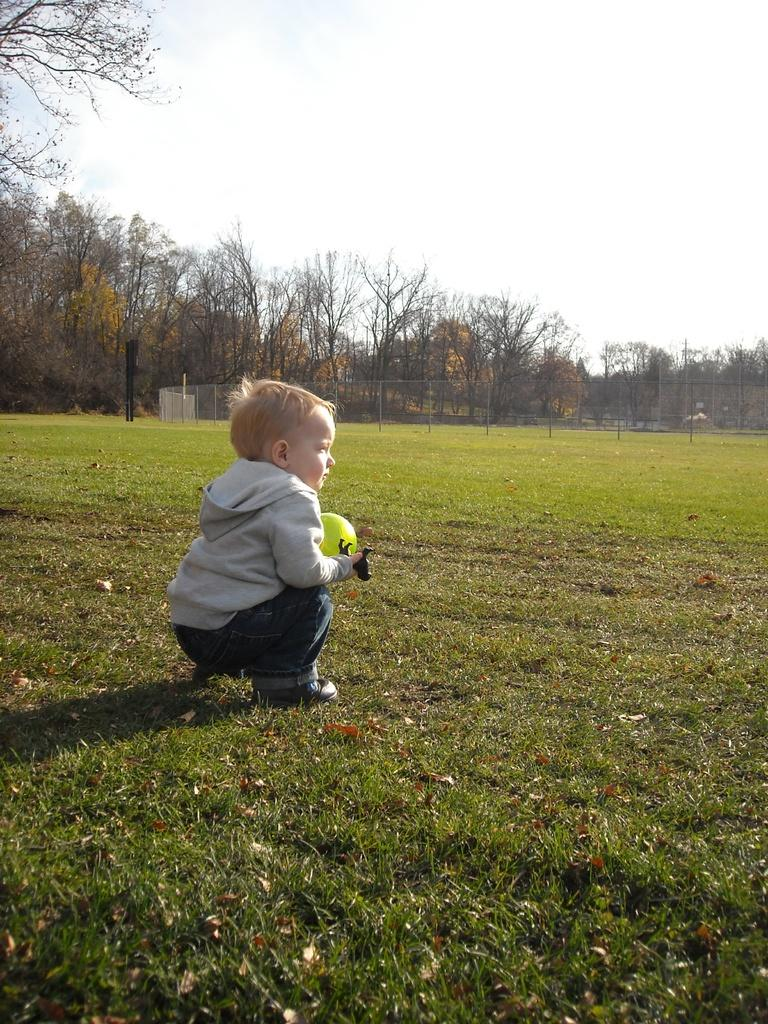What is the main subject of the image? The main subject of the image is a kid. What is the kid holding in the image? The kid is holding a toy in the image. Where is the toy located in the image? The toy is on the grass in the image. What can be seen in the background of the image? In the background of the image, there is a mesh, rods, trees, and the sky. What other object is present in the image? There is a ball in the image. What type of fish can be seen swimming in the background of the image? There are no fish present in the image; the background features a mesh, rods, trees, and the sky. 